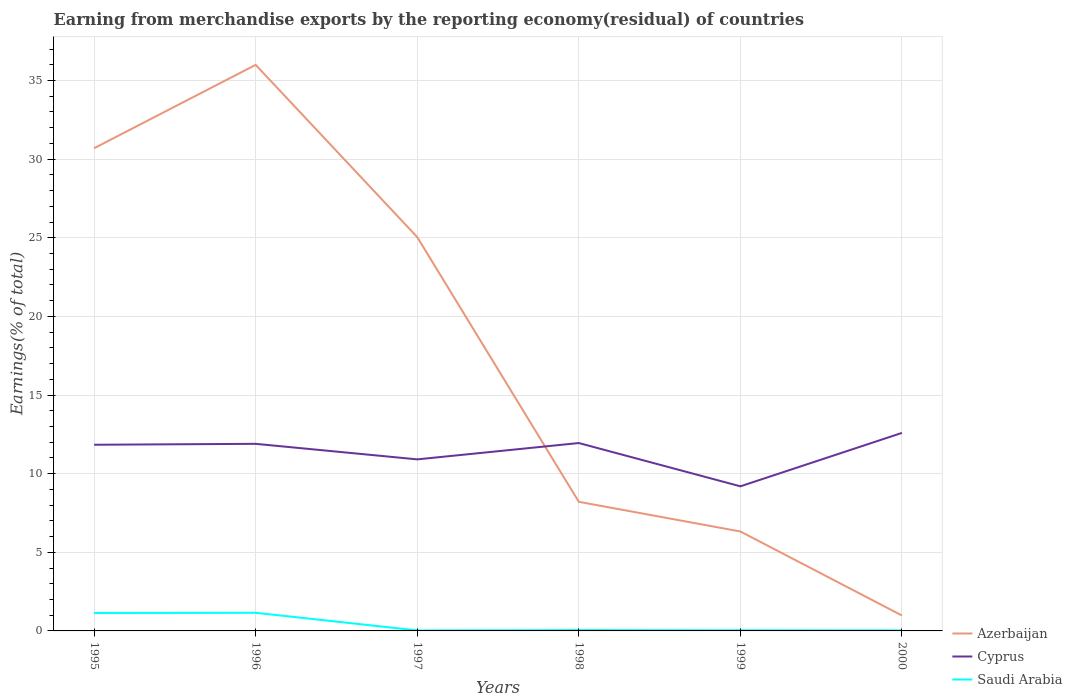How many different coloured lines are there?
Offer a terse response. 3. Does the line corresponding to Cyprus intersect with the line corresponding to Saudi Arabia?
Provide a succinct answer. No. Is the number of lines equal to the number of legend labels?
Your answer should be very brief. Yes. Across all years, what is the maximum percentage of amount earned from merchandise exports in Saudi Arabia?
Keep it short and to the point. 0.03. In which year was the percentage of amount earned from merchandise exports in Cyprus maximum?
Your response must be concise. 1999. What is the total percentage of amount earned from merchandise exports in Saudi Arabia in the graph?
Make the answer very short. 1.11. What is the difference between the highest and the second highest percentage of amount earned from merchandise exports in Cyprus?
Offer a very short reply. 3.4. Is the percentage of amount earned from merchandise exports in Saudi Arabia strictly greater than the percentage of amount earned from merchandise exports in Cyprus over the years?
Offer a very short reply. Yes. How many lines are there?
Ensure brevity in your answer.  3. How many years are there in the graph?
Your answer should be very brief. 6. What is the difference between two consecutive major ticks on the Y-axis?
Offer a very short reply. 5. Are the values on the major ticks of Y-axis written in scientific E-notation?
Give a very brief answer. No. Does the graph contain any zero values?
Your answer should be compact. No. Where does the legend appear in the graph?
Provide a short and direct response. Bottom right. How are the legend labels stacked?
Offer a very short reply. Vertical. What is the title of the graph?
Your response must be concise. Earning from merchandise exports by the reporting economy(residual) of countries. Does "Trinidad and Tobago" appear as one of the legend labels in the graph?
Offer a very short reply. No. What is the label or title of the X-axis?
Your answer should be very brief. Years. What is the label or title of the Y-axis?
Your answer should be very brief. Earnings(% of total). What is the Earnings(% of total) of Azerbaijan in 1995?
Give a very brief answer. 30.7. What is the Earnings(% of total) in Cyprus in 1995?
Offer a terse response. 11.84. What is the Earnings(% of total) of Saudi Arabia in 1995?
Your response must be concise. 1.14. What is the Earnings(% of total) of Azerbaijan in 1996?
Offer a terse response. 36. What is the Earnings(% of total) of Cyprus in 1996?
Your answer should be compact. 11.9. What is the Earnings(% of total) in Saudi Arabia in 1996?
Provide a succinct answer. 1.15. What is the Earnings(% of total) in Azerbaijan in 1997?
Provide a short and direct response. 25.04. What is the Earnings(% of total) in Cyprus in 1997?
Make the answer very short. 10.91. What is the Earnings(% of total) of Saudi Arabia in 1997?
Make the answer very short. 0.03. What is the Earnings(% of total) of Azerbaijan in 1998?
Offer a terse response. 8.21. What is the Earnings(% of total) in Cyprus in 1998?
Your response must be concise. 11.95. What is the Earnings(% of total) of Saudi Arabia in 1998?
Offer a terse response. 0.06. What is the Earnings(% of total) in Azerbaijan in 1999?
Give a very brief answer. 6.32. What is the Earnings(% of total) in Cyprus in 1999?
Make the answer very short. 9.2. What is the Earnings(% of total) of Saudi Arabia in 1999?
Your answer should be very brief. 0.04. What is the Earnings(% of total) of Azerbaijan in 2000?
Offer a very short reply. 0.98. What is the Earnings(% of total) in Cyprus in 2000?
Your response must be concise. 12.59. What is the Earnings(% of total) of Saudi Arabia in 2000?
Your answer should be compact. 0.03. Across all years, what is the maximum Earnings(% of total) of Azerbaijan?
Provide a succinct answer. 36. Across all years, what is the maximum Earnings(% of total) in Cyprus?
Keep it short and to the point. 12.59. Across all years, what is the maximum Earnings(% of total) of Saudi Arabia?
Make the answer very short. 1.15. Across all years, what is the minimum Earnings(% of total) in Azerbaijan?
Give a very brief answer. 0.98. Across all years, what is the minimum Earnings(% of total) in Cyprus?
Provide a short and direct response. 9.2. Across all years, what is the minimum Earnings(% of total) in Saudi Arabia?
Offer a terse response. 0.03. What is the total Earnings(% of total) of Azerbaijan in the graph?
Your answer should be compact. 107.25. What is the total Earnings(% of total) in Cyprus in the graph?
Offer a terse response. 68.38. What is the total Earnings(% of total) in Saudi Arabia in the graph?
Provide a succinct answer. 2.46. What is the difference between the Earnings(% of total) of Azerbaijan in 1995 and that in 1996?
Offer a very short reply. -5.3. What is the difference between the Earnings(% of total) of Cyprus in 1995 and that in 1996?
Your answer should be compact. -0.06. What is the difference between the Earnings(% of total) of Saudi Arabia in 1995 and that in 1996?
Keep it short and to the point. -0.01. What is the difference between the Earnings(% of total) in Azerbaijan in 1995 and that in 1997?
Make the answer very short. 5.65. What is the difference between the Earnings(% of total) in Cyprus in 1995 and that in 1997?
Keep it short and to the point. 0.93. What is the difference between the Earnings(% of total) in Saudi Arabia in 1995 and that in 1997?
Your response must be concise. 1.11. What is the difference between the Earnings(% of total) in Azerbaijan in 1995 and that in 1998?
Provide a succinct answer. 22.49. What is the difference between the Earnings(% of total) in Cyprus in 1995 and that in 1998?
Provide a short and direct response. -0.11. What is the difference between the Earnings(% of total) of Saudi Arabia in 1995 and that in 1998?
Make the answer very short. 1.09. What is the difference between the Earnings(% of total) in Azerbaijan in 1995 and that in 1999?
Keep it short and to the point. 24.37. What is the difference between the Earnings(% of total) of Cyprus in 1995 and that in 1999?
Give a very brief answer. 2.64. What is the difference between the Earnings(% of total) of Saudi Arabia in 1995 and that in 1999?
Make the answer very short. 1.1. What is the difference between the Earnings(% of total) of Azerbaijan in 1995 and that in 2000?
Keep it short and to the point. 29.72. What is the difference between the Earnings(% of total) in Cyprus in 1995 and that in 2000?
Your answer should be compact. -0.75. What is the difference between the Earnings(% of total) of Saudi Arabia in 1995 and that in 2000?
Ensure brevity in your answer.  1.11. What is the difference between the Earnings(% of total) of Azerbaijan in 1996 and that in 1997?
Offer a very short reply. 10.96. What is the difference between the Earnings(% of total) of Saudi Arabia in 1996 and that in 1997?
Your response must be concise. 1.12. What is the difference between the Earnings(% of total) of Azerbaijan in 1996 and that in 1998?
Provide a short and direct response. 27.79. What is the difference between the Earnings(% of total) in Cyprus in 1996 and that in 1998?
Ensure brevity in your answer.  -0.05. What is the difference between the Earnings(% of total) in Saudi Arabia in 1996 and that in 1998?
Provide a succinct answer. 1.1. What is the difference between the Earnings(% of total) of Azerbaijan in 1996 and that in 1999?
Make the answer very short. 29.67. What is the difference between the Earnings(% of total) of Cyprus in 1996 and that in 1999?
Provide a short and direct response. 2.7. What is the difference between the Earnings(% of total) of Saudi Arabia in 1996 and that in 1999?
Ensure brevity in your answer.  1.11. What is the difference between the Earnings(% of total) of Azerbaijan in 1996 and that in 2000?
Your answer should be very brief. 35.02. What is the difference between the Earnings(% of total) of Cyprus in 1996 and that in 2000?
Provide a short and direct response. -0.7. What is the difference between the Earnings(% of total) in Saudi Arabia in 1996 and that in 2000?
Provide a succinct answer. 1.12. What is the difference between the Earnings(% of total) of Azerbaijan in 1997 and that in 1998?
Offer a very short reply. 16.83. What is the difference between the Earnings(% of total) in Cyprus in 1997 and that in 1998?
Your response must be concise. -1.04. What is the difference between the Earnings(% of total) of Saudi Arabia in 1997 and that in 1998?
Your answer should be very brief. -0.02. What is the difference between the Earnings(% of total) of Azerbaijan in 1997 and that in 1999?
Make the answer very short. 18.72. What is the difference between the Earnings(% of total) of Cyprus in 1997 and that in 1999?
Your response must be concise. 1.71. What is the difference between the Earnings(% of total) in Saudi Arabia in 1997 and that in 1999?
Keep it short and to the point. -0.01. What is the difference between the Earnings(% of total) in Azerbaijan in 1997 and that in 2000?
Your answer should be compact. 24.06. What is the difference between the Earnings(% of total) of Cyprus in 1997 and that in 2000?
Provide a short and direct response. -1.68. What is the difference between the Earnings(% of total) in Saudi Arabia in 1997 and that in 2000?
Give a very brief answer. -0. What is the difference between the Earnings(% of total) of Azerbaijan in 1998 and that in 1999?
Offer a very short reply. 1.89. What is the difference between the Earnings(% of total) in Cyprus in 1998 and that in 1999?
Offer a terse response. 2.75. What is the difference between the Earnings(% of total) in Saudi Arabia in 1998 and that in 1999?
Your response must be concise. 0.01. What is the difference between the Earnings(% of total) in Azerbaijan in 1998 and that in 2000?
Your answer should be very brief. 7.23. What is the difference between the Earnings(% of total) of Cyprus in 1998 and that in 2000?
Your response must be concise. -0.65. What is the difference between the Earnings(% of total) of Saudi Arabia in 1998 and that in 2000?
Make the answer very short. 0.02. What is the difference between the Earnings(% of total) of Azerbaijan in 1999 and that in 2000?
Provide a short and direct response. 5.34. What is the difference between the Earnings(% of total) in Cyprus in 1999 and that in 2000?
Keep it short and to the point. -3.4. What is the difference between the Earnings(% of total) of Saudi Arabia in 1999 and that in 2000?
Your answer should be very brief. 0.01. What is the difference between the Earnings(% of total) in Azerbaijan in 1995 and the Earnings(% of total) in Cyprus in 1996?
Your answer should be very brief. 18.8. What is the difference between the Earnings(% of total) in Azerbaijan in 1995 and the Earnings(% of total) in Saudi Arabia in 1996?
Offer a terse response. 29.54. What is the difference between the Earnings(% of total) in Cyprus in 1995 and the Earnings(% of total) in Saudi Arabia in 1996?
Offer a very short reply. 10.69. What is the difference between the Earnings(% of total) of Azerbaijan in 1995 and the Earnings(% of total) of Cyprus in 1997?
Your response must be concise. 19.79. What is the difference between the Earnings(% of total) of Azerbaijan in 1995 and the Earnings(% of total) of Saudi Arabia in 1997?
Offer a terse response. 30.66. What is the difference between the Earnings(% of total) of Cyprus in 1995 and the Earnings(% of total) of Saudi Arabia in 1997?
Offer a very short reply. 11.81. What is the difference between the Earnings(% of total) of Azerbaijan in 1995 and the Earnings(% of total) of Cyprus in 1998?
Your answer should be very brief. 18.75. What is the difference between the Earnings(% of total) of Azerbaijan in 1995 and the Earnings(% of total) of Saudi Arabia in 1998?
Make the answer very short. 30.64. What is the difference between the Earnings(% of total) in Cyprus in 1995 and the Earnings(% of total) in Saudi Arabia in 1998?
Ensure brevity in your answer.  11.78. What is the difference between the Earnings(% of total) of Azerbaijan in 1995 and the Earnings(% of total) of Cyprus in 1999?
Your answer should be very brief. 21.5. What is the difference between the Earnings(% of total) of Azerbaijan in 1995 and the Earnings(% of total) of Saudi Arabia in 1999?
Ensure brevity in your answer.  30.65. What is the difference between the Earnings(% of total) in Cyprus in 1995 and the Earnings(% of total) in Saudi Arabia in 1999?
Keep it short and to the point. 11.8. What is the difference between the Earnings(% of total) of Azerbaijan in 1995 and the Earnings(% of total) of Cyprus in 2000?
Offer a terse response. 18.1. What is the difference between the Earnings(% of total) of Azerbaijan in 1995 and the Earnings(% of total) of Saudi Arabia in 2000?
Your response must be concise. 30.66. What is the difference between the Earnings(% of total) in Cyprus in 1995 and the Earnings(% of total) in Saudi Arabia in 2000?
Your answer should be very brief. 11.81. What is the difference between the Earnings(% of total) in Azerbaijan in 1996 and the Earnings(% of total) in Cyprus in 1997?
Your response must be concise. 25.09. What is the difference between the Earnings(% of total) in Azerbaijan in 1996 and the Earnings(% of total) in Saudi Arabia in 1997?
Keep it short and to the point. 35.97. What is the difference between the Earnings(% of total) in Cyprus in 1996 and the Earnings(% of total) in Saudi Arabia in 1997?
Ensure brevity in your answer.  11.87. What is the difference between the Earnings(% of total) in Azerbaijan in 1996 and the Earnings(% of total) in Cyprus in 1998?
Your answer should be compact. 24.05. What is the difference between the Earnings(% of total) in Azerbaijan in 1996 and the Earnings(% of total) in Saudi Arabia in 1998?
Make the answer very short. 35.94. What is the difference between the Earnings(% of total) of Cyprus in 1996 and the Earnings(% of total) of Saudi Arabia in 1998?
Provide a short and direct response. 11.84. What is the difference between the Earnings(% of total) in Azerbaijan in 1996 and the Earnings(% of total) in Cyprus in 1999?
Give a very brief answer. 26.8. What is the difference between the Earnings(% of total) in Azerbaijan in 1996 and the Earnings(% of total) in Saudi Arabia in 1999?
Keep it short and to the point. 35.95. What is the difference between the Earnings(% of total) in Cyprus in 1996 and the Earnings(% of total) in Saudi Arabia in 1999?
Keep it short and to the point. 11.86. What is the difference between the Earnings(% of total) in Azerbaijan in 1996 and the Earnings(% of total) in Cyprus in 2000?
Offer a very short reply. 23.4. What is the difference between the Earnings(% of total) of Azerbaijan in 1996 and the Earnings(% of total) of Saudi Arabia in 2000?
Ensure brevity in your answer.  35.96. What is the difference between the Earnings(% of total) of Cyprus in 1996 and the Earnings(% of total) of Saudi Arabia in 2000?
Give a very brief answer. 11.86. What is the difference between the Earnings(% of total) in Azerbaijan in 1997 and the Earnings(% of total) in Cyprus in 1998?
Give a very brief answer. 13.09. What is the difference between the Earnings(% of total) in Azerbaijan in 1997 and the Earnings(% of total) in Saudi Arabia in 1998?
Offer a terse response. 24.99. What is the difference between the Earnings(% of total) in Cyprus in 1997 and the Earnings(% of total) in Saudi Arabia in 1998?
Offer a terse response. 10.85. What is the difference between the Earnings(% of total) in Azerbaijan in 1997 and the Earnings(% of total) in Cyprus in 1999?
Provide a succinct answer. 15.85. What is the difference between the Earnings(% of total) in Azerbaijan in 1997 and the Earnings(% of total) in Saudi Arabia in 1999?
Your response must be concise. 25. What is the difference between the Earnings(% of total) in Cyprus in 1997 and the Earnings(% of total) in Saudi Arabia in 1999?
Ensure brevity in your answer.  10.87. What is the difference between the Earnings(% of total) in Azerbaijan in 1997 and the Earnings(% of total) in Cyprus in 2000?
Keep it short and to the point. 12.45. What is the difference between the Earnings(% of total) of Azerbaijan in 1997 and the Earnings(% of total) of Saudi Arabia in 2000?
Your answer should be compact. 25.01. What is the difference between the Earnings(% of total) of Cyprus in 1997 and the Earnings(% of total) of Saudi Arabia in 2000?
Keep it short and to the point. 10.88. What is the difference between the Earnings(% of total) in Azerbaijan in 1998 and the Earnings(% of total) in Cyprus in 1999?
Offer a very short reply. -0.99. What is the difference between the Earnings(% of total) in Azerbaijan in 1998 and the Earnings(% of total) in Saudi Arabia in 1999?
Give a very brief answer. 8.17. What is the difference between the Earnings(% of total) in Cyprus in 1998 and the Earnings(% of total) in Saudi Arabia in 1999?
Give a very brief answer. 11.9. What is the difference between the Earnings(% of total) of Azerbaijan in 1998 and the Earnings(% of total) of Cyprus in 2000?
Keep it short and to the point. -4.38. What is the difference between the Earnings(% of total) in Azerbaijan in 1998 and the Earnings(% of total) in Saudi Arabia in 2000?
Provide a short and direct response. 8.18. What is the difference between the Earnings(% of total) in Cyprus in 1998 and the Earnings(% of total) in Saudi Arabia in 2000?
Offer a terse response. 11.91. What is the difference between the Earnings(% of total) of Azerbaijan in 1999 and the Earnings(% of total) of Cyprus in 2000?
Offer a terse response. -6.27. What is the difference between the Earnings(% of total) of Azerbaijan in 1999 and the Earnings(% of total) of Saudi Arabia in 2000?
Provide a succinct answer. 6.29. What is the difference between the Earnings(% of total) in Cyprus in 1999 and the Earnings(% of total) in Saudi Arabia in 2000?
Offer a very short reply. 9.16. What is the average Earnings(% of total) of Azerbaijan per year?
Provide a short and direct response. 17.87. What is the average Earnings(% of total) in Cyprus per year?
Provide a short and direct response. 11.4. What is the average Earnings(% of total) of Saudi Arabia per year?
Provide a short and direct response. 0.41. In the year 1995, what is the difference between the Earnings(% of total) of Azerbaijan and Earnings(% of total) of Cyprus?
Ensure brevity in your answer.  18.86. In the year 1995, what is the difference between the Earnings(% of total) in Azerbaijan and Earnings(% of total) in Saudi Arabia?
Your answer should be very brief. 29.55. In the year 1995, what is the difference between the Earnings(% of total) of Cyprus and Earnings(% of total) of Saudi Arabia?
Keep it short and to the point. 10.7. In the year 1996, what is the difference between the Earnings(% of total) in Azerbaijan and Earnings(% of total) in Cyprus?
Make the answer very short. 24.1. In the year 1996, what is the difference between the Earnings(% of total) of Azerbaijan and Earnings(% of total) of Saudi Arabia?
Your answer should be compact. 34.84. In the year 1996, what is the difference between the Earnings(% of total) in Cyprus and Earnings(% of total) in Saudi Arabia?
Your answer should be compact. 10.75. In the year 1997, what is the difference between the Earnings(% of total) of Azerbaijan and Earnings(% of total) of Cyprus?
Provide a succinct answer. 14.13. In the year 1997, what is the difference between the Earnings(% of total) in Azerbaijan and Earnings(% of total) in Saudi Arabia?
Your answer should be very brief. 25.01. In the year 1997, what is the difference between the Earnings(% of total) in Cyprus and Earnings(% of total) in Saudi Arabia?
Your answer should be compact. 10.88. In the year 1998, what is the difference between the Earnings(% of total) of Azerbaijan and Earnings(% of total) of Cyprus?
Provide a succinct answer. -3.74. In the year 1998, what is the difference between the Earnings(% of total) in Azerbaijan and Earnings(% of total) in Saudi Arabia?
Your answer should be very brief. 8.16. In the year 1998, what is the difference between the Earnings(% of total) in Cyprus and Earnings(% of total) in Saudi Arabia?
Provide a succinct answer. 11.89. In the year 1999, what is the difference between the Earnings(% of total) of Azerbaijan and Earnings(% of total) of Cyprus?
Make the answer very short. -2.87. In the year 1999, what is the difference between the Earnings(% of total) in Azerbaijan and Earnings(% of total) in Saudi Arabia?
Offer a terse response. 6.28. In the year 1999, what is the difference between the Earnings(% of total) of Cyprus and Earnings(% of total) of Saudi Arabia?
Give a very brief answer. 9.15. In the year 2000, what is the difference between the Earnings(% of total) in Azerbaijan and Earnings(% of total) in Cyprus?
Make the answer very short. -11.61. In the year 2000, what is the difference between the Earnings(% of total) in Azerbaijan and Earnings(% of total) in Saudi Arabia?
Your response must be concise. 0.95. In the year 2000, what is the difference between the Earnings(% of total) in Cyprus and Earnings(% of total) in Saudi Arabia?
Ensure brevity in your answer.  12.56. What is the ratio of the Earnings(% of total) of Azerbaijan in 1995 to that in 1996?
Offer a very short reply. 0.85. What is the ratio of the Earnings(% of total) of Saudi Arabia in 1995 to that in 1996?
Make the answer very short. 0.99. What is the ratio of the Earnings(% of total) in Azerbaijan in 1995 to that in 1997?
Your response must be concise. 1.23. What is the ratio of the Earnings(% of total) of Cyprus in 1995 to that in 1997?
Ensure brevity in your answer.  1.09. What is the ratio of the Earnings(% of total) of Saudi Arabia in 1995 to that in 1997?
Give a very brief answer. 35.78. What is the ratio of the Earnings(% of total) of Azerbaijan in 1995 to that in 1998?
Provide a succinct answer. 3.74. What is the ratio of the Earnings(% of total) in Cyprus in 1995 to that in 1998?
Give a very brief answer. 0.99. What is the ratio of the Earnings(% of total) in Saudi Arabia in 1995 to that in 1998?
Offer a terse response. 20.72. What is the ratio of the Earnings(% of total) in Azerbaijan in 1995 to that in 1999?
Offer a terse response. 4.85. What is the ratio of the Earnings(% of total) in Cyprus in 1995 to that in 1999?
Offer a very short reply. 1.29. What is the ratio of the Earnings(% of total) of Saudi Arabia in 1995 to that in 1999?
Keep it short and to the point. 26.68. What is the ratio of the Earnings(% of total) in Azerbaijan in 1995 to that in 2000?
Keep it short and to the point. 31.33. What is the ratio of the Earnings(% of total) of Cyprus in 1995 to that in 2000?
Provide a succinct answer. 0.94. What is the ratio of the Earnings(% of total) in Saudi Arabia in 1995 to that in 2000?
Give a very brief answer. 33.81. What is the ratio of the Earnings(% of total) in Azerbaijan in 1996 to that in 1997?
Make the answer very short. 1.44. What is the ratio of the Earnings(% of total) of Cyprus in 1996 to that in 1997?
Offer a terse response. 1.09. What is the ratio of the Earnings(% of total) of Saudi Arabia in 1996 to that in 1997?
Your response must be concise. 36.14. What is the ratio of the Earnings(% of total) in Azerbaijan in 1996 to that in 1998?
Offer a very short reply. 4.38. What is the ratio of the Earnings(% of total) of Saudi Arabia in 1996 to that in 1998?
Your response must be concise. 20.92. What is the ratio of the Earnings(% of total) in Azerbaijan in 1996 to that in 1999?
Ensure brevity in your answer.  5.69. What is the ratio of the Earnings(% of total) in Cyprus in 1996 to that in 1999?
Give a very brief answer. 1.29. What is the ratio of the Earnings(% of total) in Saudi Arabia in 1996 to that in 1999?
Offer a very short reply. 26.95. What is the ratio of the Earnings(% of total) of Azerbaijan in 1996 to that in 2000?
Offer a terse response. 36.74. What is the ratio of the Earnings(% of total) of Cyprus in 1996 to that in 2000?
Your answer should be very brief. 0.94. What is the ratio of the Earnings(% of total) of Saudi Arabia in 1996 to that in 2000?
Your answer should be very brief. 34.15. What is the ratio of the Earnings(% of total) of Azerbaijan in 1997 to that in 1998?
Provide a short and direct response. 3.05. What is the ratio of the Earnings(% of total) in Cyprus in 1997 to that in 1998?
Your response must be concise. 0.91. What is the ratio of the Earnings(% of total) of Saudi Arabia in 1997 to that in 1998?
Make the answer very short. 0.58. What is the ratio of the Earnings(% of total) in Azerbaijan in 1997 to that in 1999?
Your answer should be very brief. 3.96. What is the ratio of the Earnings(% of total) in Cyprus in 1997 to that in 1999?
Your answer should be compact. 1.19. What is the ratio of the Earnings(% of total) of Saudi Arabia in 1997 to that in 1999?
Keep it short and to the point. 0.75. What is the ratio of the Earnings(% of total) of Azerbaijan in 1997 to that in 2000?
Your response must be concise. 25.56. What is the ratio of the Earnings(% of total) of Cyprus in 1997 to that in 2000?
Your answer should be compact. 0.87. What is the ratio of the Earnings(% of total) of Saudi Arabia in 1997 to that in 2000?
Ensure brevity in your answer.  0.94. What is the ratio of the Earnings(% of total) of Azerbaijan in 1998 to that in 1999?
Provide a succinct answer. 1.3. What is the ratio of the Earnings(% of total) of Cyprus in 1998 to that in 1999?
Keep it short and to the point. 1.3. What is the ratio of the Earnings(% of total) in Saudi Arabia in 1998 to that in 1999?
Ensure brevity in your answer.  1.29. What is the ratio of the Earnings(% of total) of Azerbaijan in 1998 to that in 2000?
Your answer should be compact. 8.38. What is the ratio of the Earnings(% of total) of Cyprus in 1998 to that in 2000?
Your answer should be compact. 0.95. What is the ratio of the Earnings(% of total) in Saudi Arabia in 1998 to that in 2000?
Your answer should be very brief. 1.63. What is the ratio of the Earnings(% of total) in Azerbaijan in 1999 to that in 2000?
Keep it short and to the point. 6.45. What is the ratio of the Earnings(% of total) in Cyprus in 1999 to that in 2000?
Your answer should be very brief. 0.73. What is the ratio of the Earnings(% of total) of Saudi Arabia in 1999 to that in 2000?
Keep it short and to the point. 1.27. What is the difference between the highest and the second highest Earnings(% of total) of Azerbaijan?
Offer a terse response. 5.3. What is the difference between the highest and the second highest Earnings(% of total) of Cyprus?
Provide a succinct answer. 0.65. What is the difference between the highest and the second highest Earnings(% of total) in Saudi Arabia?
Provide a short and direct response. 0.01. What is the difference between the highest and the lowest Earnings(% of total) of Azerbaijan?
Offer a terse response. 35.02. What is the difference between the highest and the lowest Earnings(% of total) in Cyprus?
Your answer should be very brief. 3.4. What is the difference between the highest and the lowest Earnings(% of total) of Saudi Arabia?
Make the answer very short. 1.12. 